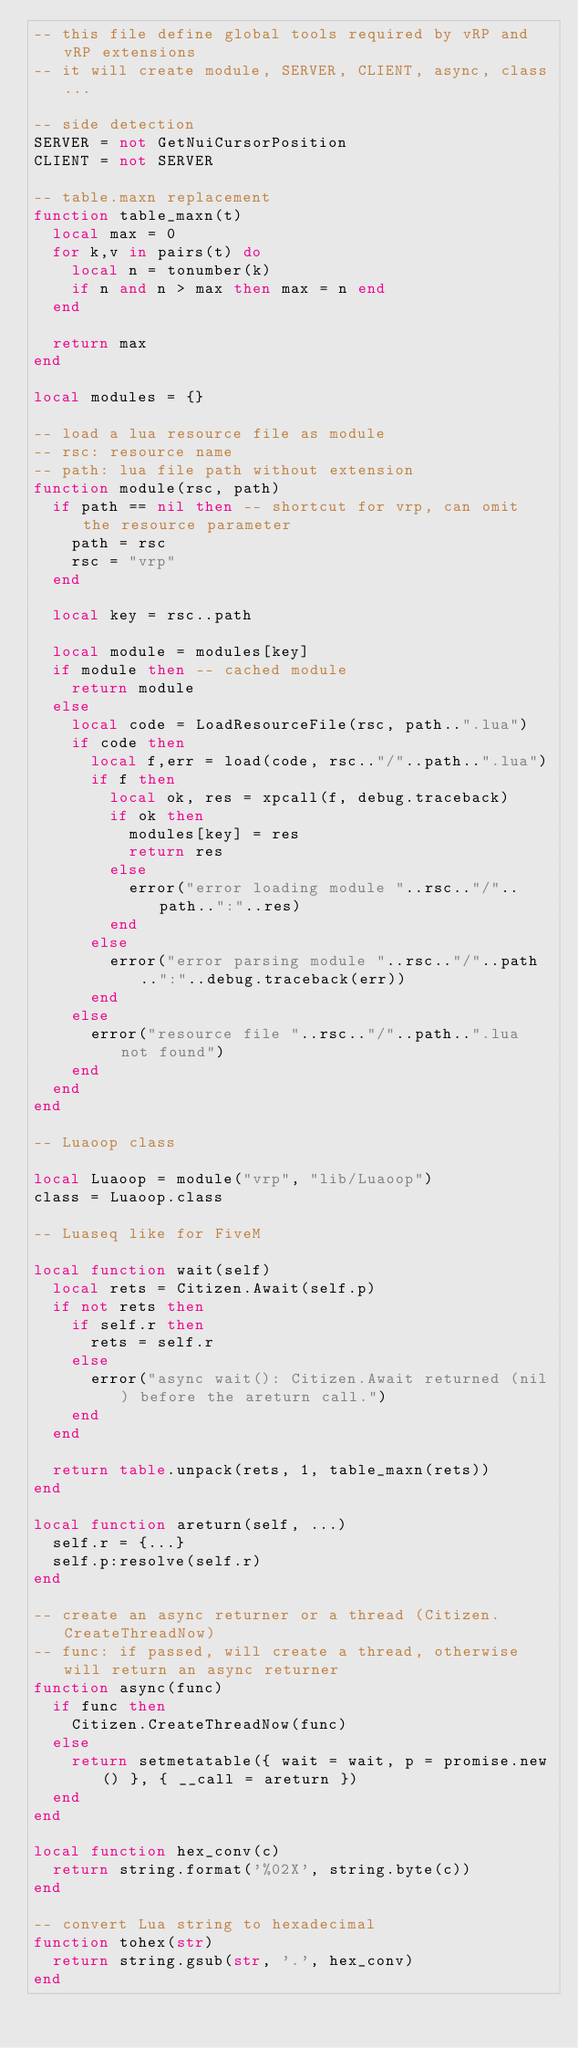Convert code to text. <code><loc_0><loc_0><loc_500><loc_500><_Lua_>-- this file define global tools required by vRP and vRP extensions
-- it will create module, SERVER, CLIENT, async, class...

-- side detection
SERVER = not GetNuiCursorPosition
CLIENT = not SERVER

-- table.maxn replacement
function table_maxn(t)
  local max = 0
  for k,v in pairs(t) do
    local n = tonumber(k)
    if n and n > max then max = n end
  end

  return max
end

local modules = {}

-- load a lua resource file as module
-- rsc: resource name
-- path: lua file path without extension
function module(rsc, path)
  if path == nil then -- shortcut for vrp, can omit the resource parameter
    path = rsc
    rsc = "vrp"
  end

  local key = rsc..path

  local module = modules[key]
  if module then -- cached module
    return module
  else
    local code = LoadResourceFile(rsc, path..".lua")
    if code then
      local f,err = load(code, rsc.."/"..path..".lua")
      if f then
        local ok, res = xpcall(f, debug.traceback)
        if ok then
          modules[key] = res
          return res
        else
          error("error loading module "..rsc.."/"..path..":"..res)
        end
      else
        error("error parsing module "..rsc.."/"..path..":"..debug.traceback(err))
      end
    else
      error("resource file "..rsc.."/"..path..".lua not found")
    end
  end
end

-- Luaoop class

local Luaoop = module("vrp", "lib/Luaoop")
class = Luaoop.class

-- Luaseq like for FiveM

local function wait(self)
  local rets = Citizen.Await(self.p)
  if not rets then
    if self.r then
      rets = self.r
    else
      error("async wait(): Citizen.Await returned (nil) before the areturn call.")
    end
  end

  return table.unpack(rets, 1, table_maxn(rets))
end

local function areturn(self, ...)
  self.r = {...}
  self.p:resolve(self.r)
end

-- create an async returner or a thread (Citizen.CreateThreadNow)
-- func: if passed, will create a thread, otherwise will return an async returner
function async(func)
  if func then
    Citizen.CreateThreadNow(func)
  else
    return setmetatable({ wait = wait, p = promise.new() }, { __call = areturn })
  end
end

local function hex_conv(c)
  return string.format('%02X', string.byte(c))
end

-- convert Lua string to hexadecimal
function tohex(str)
  return string.gsub(str, '.', hex_conv)
end

</code> 